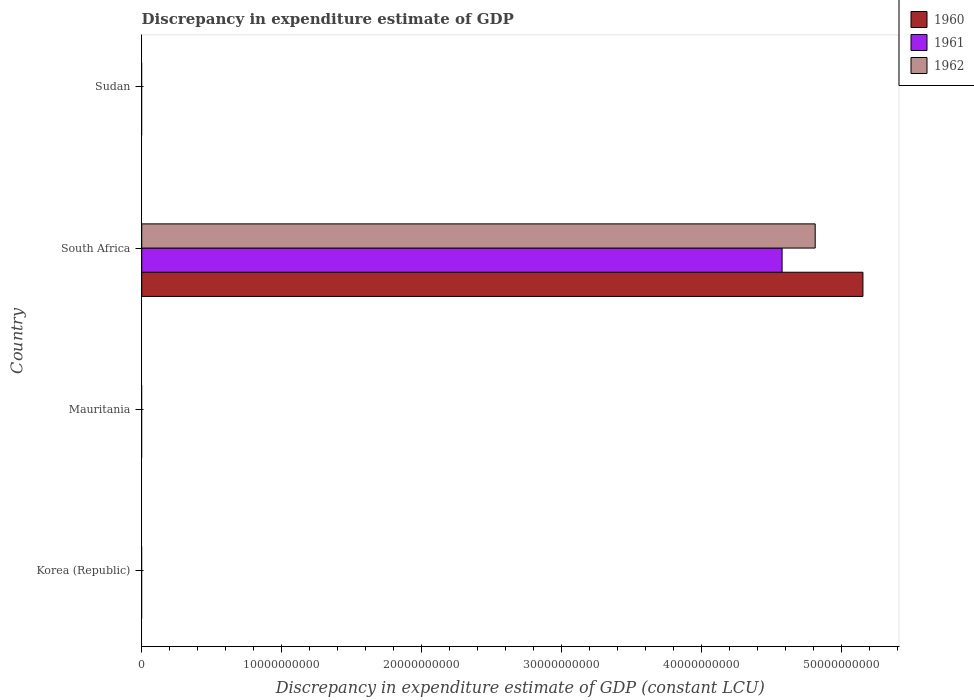Are the number of bars on each tick of the Y-axis equal?
Ensure brevity in your answer.  No. How many bars are there on the 3rd tick from the bottom?
Your answer should be very brief. 3. What is the label of the 1st group of bars from the top?
Provide a succinct answer. Sudan. In how many cases, is the number of bars for a given country not equal to the number of legend labels?
Keep it short and to the point. 3. What is the discrepancy in expenditure estimate of GDP in 1960 in South Africa?
Provide a short and direct response. 5.15e+1. Across all countries, what is the maximum discrepancy in expenditure estimate of GDP in 1961?
Provide a succinct answer. 4.58e+1. Across all countries, what is the minimum discrepancy in expenditure estimate of GDP in 1961?
Your answer should be very brief. 0. In which country was the discrepancy in expenditure estimate of GDP in 1962 maximum?
Provide a short and direct response. South Africa. What is the total discrepancy in expenditure estimate of GDP in 1961 in the graph?
Your answer should be very brief. 4.58e+1. What is the difference between the discrepancy in expenditure estimate of GDP in 1962 in South Africa and the discrepancy in expenditure estimate of GDP in 1961 in Korea (Republic)?
Your answer should be compact. 4.81e+1. What is the average discrepancy in expenditure estimate of GDP in 1961 per country?
Keep it short and to the point. 1.14e+1. What is the difference between the discrepancy in expenditure estimate of GDP in 1960 and discrepancy in expenditure estimate of GDP in 1961 in South Africa?
Offer a terse response. 5.78e+09. In how many countries, is the discrepancy in expenditure estimate of GDP in 1962 greater than 44000000000 LCU?
Give a very brief answer. 1. What is the difference between the highest and the lowest discrepancy in expenditure estimate of GDP in 1962?
Ensure brevity in your answer.  4.81e+1. In how many countries, is the discrepancy in expenditure estimate of GDP in 1960 greater than the average discrepancy in expenditure estimate of GDP in 1960 taken over all countries?
Keep it short and to the point. 1. Is it the case that in every country, the sum of the discrepancy in expenditure estimate of GDP in 1960 and discrepancy in expenditure estimate of GDP in 1961 is greater than the discrepancy in expenditure estimate of GDP in 1962?
Offer a very short reply. No. How many countries are there in the graph?
Your answer should be very brief. 4. What is the difference between two consecutive major ticks on the X-axis?
Offer a very short reply. 1.00e+1. Are the values on the major ticks of X-axis written in scientific E-notation?
Your response must be concise. No. Does the graph contain any zero values?
Offer a terse response. Yes. Does the graph contain grids?
Give a very brief answer. No. How many legend labels are there?
Ensure brevity in your answer.  3. What is the title of the graph?
Provide a succinct answer. Discrepancy in expenditure estimate of GDP. What is the label or title of the X-axis?
Ensure brevity in your answer.  Discrepancy in expenditure estimate of GDP (constant LCU). What is the label or title of the Y-axis?
Make the answer very short. Country. What is the Discrepancy in expenditure estimate of GDP (constant LCU) in 1961 in Korea (Republic)?
Your answer should be compact. 0. What is the Discrepancy in expenditure estimate of GDP (constant LCU) of 1962 in Korea (Republic)?
Give a very brief answer. 0. What is the Discrepancy in expenditure estimate of GDP (constant LCU) of 1960 in South Africa?
Offer a terse response. 5.15e+1. What is the Discrepancy in expenditure estimate of GDP (constant LCU) of 1961 in South Africa?
Give a very brief answer. 4.58e+1. What is the Discrepancy in expenditure estimate of GDP (constant LCU) of 1962 in South Africa?
Keep it short and to the point. 4.81e+1. What is the Discrepancy in expenditure estimate of GDP (constant LCU) in 1960 in Sudan?
Offer a very short reply. 0. Across all countries, what is the maximum Discrepancy in expenditure estimate of GDP (constant LCU) in 1960?
Keep it short and to the point. 5.15e+1. Across all countries, what is the maximum Discrepancy in expenditure estimate of GDP (constant LCU) of 1961?
Make the answer very short. 4.58e+1. Across all countries, what is the maximum Discrepancy in expenditure estimate of GDP (constant LCU) of 1962?
Ensure brevity in your answer.  4.81e+1. What is the total Discrepancy in expenditure estimate of GDP (constant LCU) in 1960 in the graph?
Keep it short and to the point. 5.15e+1. What is the total Discrepancy in expenditure estimate of GDP (constant LCU) in 1961 in the graph?
Offer a terse response. 4.58e+1. What is the total Discrepancy in expenditure estimate of GDP (constant LCU) in 1962 in the graph?
Your answer should be very brief. 4.81e+1. What is the average Discrepancy in expenditure estimate of GDP (constant LCU) in 1960 per country?
Your response must be concise. 1.29e+1. What is the average Discrepancy in expenditure estimate of GDP (constant LCU) in 1961 per country?
Ensure brevity in your answer.  1.14e+1. What is the average Discrepancy in expenditure estimate of GDP (constant LCU) of 1962 per country?
Your answer should be very brief. 1.20e+1. What is the difference between the Discrepancy in expenditure estimate of GDP (constant LCU) in 1960 and Discrepancy in expenditure estimate of GDP (constant LCU) in 1961 in South Africa?
Offer a terse response. 5.78e+09. What is the difference between the Discrepancy in expenditure estimate of GDP (constant LCU) in 1960 and Discrepancy in expenditure estimate of GDP (constant LCU) in 1962 in South Africa?
Your answer should be compact. 3.41e+09. What is the difference between the Discrepancy in expenditure estimate of GDP (constant LCU) in 1961 and Discrepancy in expenditure estimate of GDP (constant LCU) in 1962 in South Africa?
Provide a succinct answer. -2.37e+09. What is the difference between the highest and the lowest Discrepancy in expenditure estimate of GDP (constant LCU) in 1960?
Offer a very short reply. 5.15e+1. What is the difference between the highest and the lowest Discrepancy in expenditure estimate of GDP (constant LCU) in 1961?
Your answer should be very brief. 4.58e+1. What is the difference between the highest and the lowest Discrepancy in expenditure estimate of GDP (constant LCU) of 1962?
Offer a very short reply. 4.81e+1. 